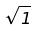<formula> <loc_0><loc_0><loc_500><loc_500>\sqrt { 1 }</formula> 